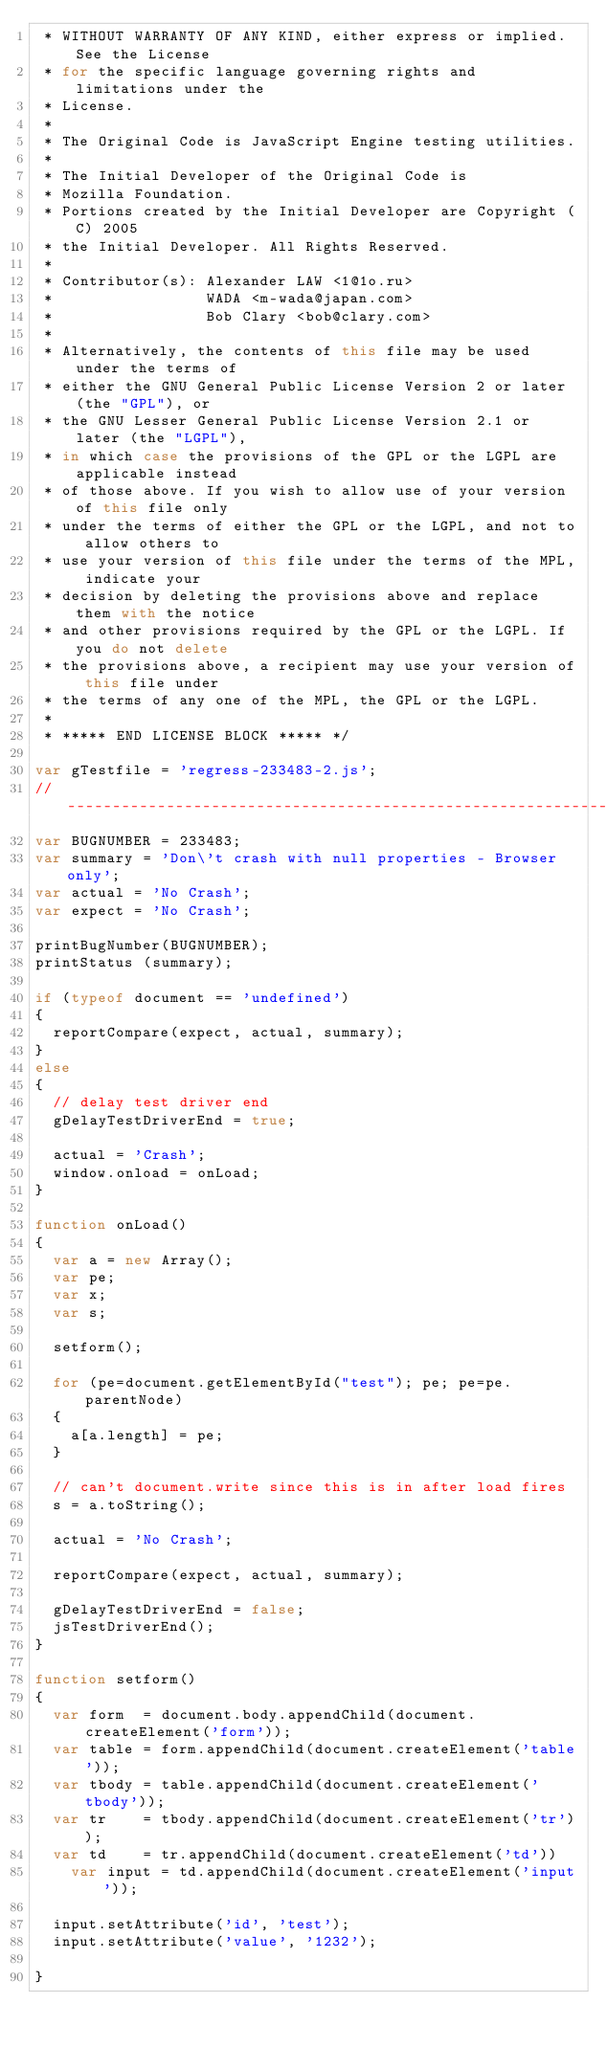Convert code to text. <code><loc_0><loc_0><loc_500><loc_500><_JavaScript_> * WITHOUT WARRANTY OF ANY KIND, either express or implied. See the License
 * for the specific language governing rights and limitations under the
 * License.
 *
 * The Original Code is JavaScript Engine testing utilities.
 *
 * The Initial Developer of the Original Code is
 * Mozilla Foundation.
 * Portions created by the Initial Developer are Copyright (C) 2005
 * the Initial Developer. All Rights Reserved.
 *
 * Contributor(s): Alexander LAW <1@1o.ru>
 *                 WADA <m-wada@japan.com>
 *                 Bob Clary <bob@clary.com>
 *
 * Alternatively, the contents of this file may be used under the terms of
 * either the GNU General Public License Version 2 or later (the "GPL"), or
 * the GNU Lesser General Public License Version 2.1 or later (the "LGPL"),
 * in which case the provisions of the GPL or the LGPL are applicable instead
 * of those above. If you wish to allow use of your version of this file only
 * under the terms of either the GPL or the LGPL, and not to allow others to
 * use your version of this file under the terms of the MPL, indicate your
 * decision by deleting the provisions above and replace them with the notice
 * and other provisions required by the GPL or the LGPL. If you do not delete
 * the provisions above, a recipient may use your version of this file under
 * the terms of any one of the MPL, the GPL or the LGPL.
 *
 * ***** END LICENSE BLOCK ***** */

var gTestfile = 'regress-233483-2.js';
//-----------------------------------------------------------------------------
var BUGNUMBER = 233483;
var summary = 'Don\'t crash with null properties - Browser only';
var actual = 'No Crash';
var expect = 'No Crash';

printBugNumber(BUGNUMBER);
printStatus (summary);

if (typeof document == 'undefined')
{
  reportCompare(expect, actual, summary);
}
else
{ 
  // delay test driver end
  gDelayTestDriverEnd = true;

  actual = 'Crash';
  window.onload = onLoad;
}

function onLoad()
{
  var a = new Array();
  var pe;
  var x;
  var s;

  setform();

  for (pe=document.getElementById("test"); pe; pe=pe.parentNode)
  {
    a[a.length] = pe;
  }

  // can't document.write since this is in after load fires
  s = a.toString();

  actual = 'No Crash';

  reportCompare(expect, actual, summary);

  gDelayTestDriverEnd = false;
  jsTestDriverEnd();
}

function setform()
{
  var form  = document.body.appendChild(document.createElement('form'));
  var table = form.appendChild(document.createElement('table'));
  var tbody = table.appendChild(document.createElement('tbody'));
  var tr    = tbody.appendChild(document.createElement('tr'));
  var td    = tr.appendChild(document.createElement('td'))
    var input = td.appendChild(document.createElement('input'));

  input.setAttribute('id', 'test');
  input.setAttribute('value', '1232');

}
</code> 